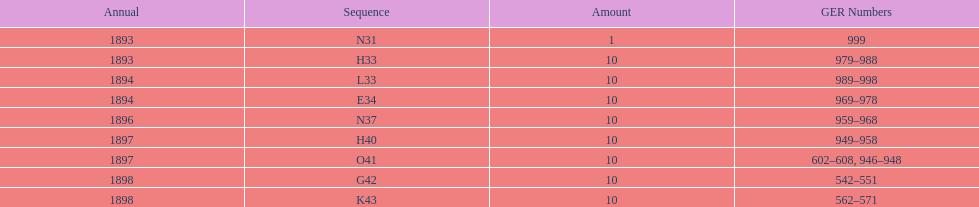Which year between 1893 and 1898 was there not an order? 1895. 